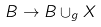Convert formula to latex. <formula><loc_0><loc_0><loc_500><loc_500>B \to B \cup _ { g } X</formula> 